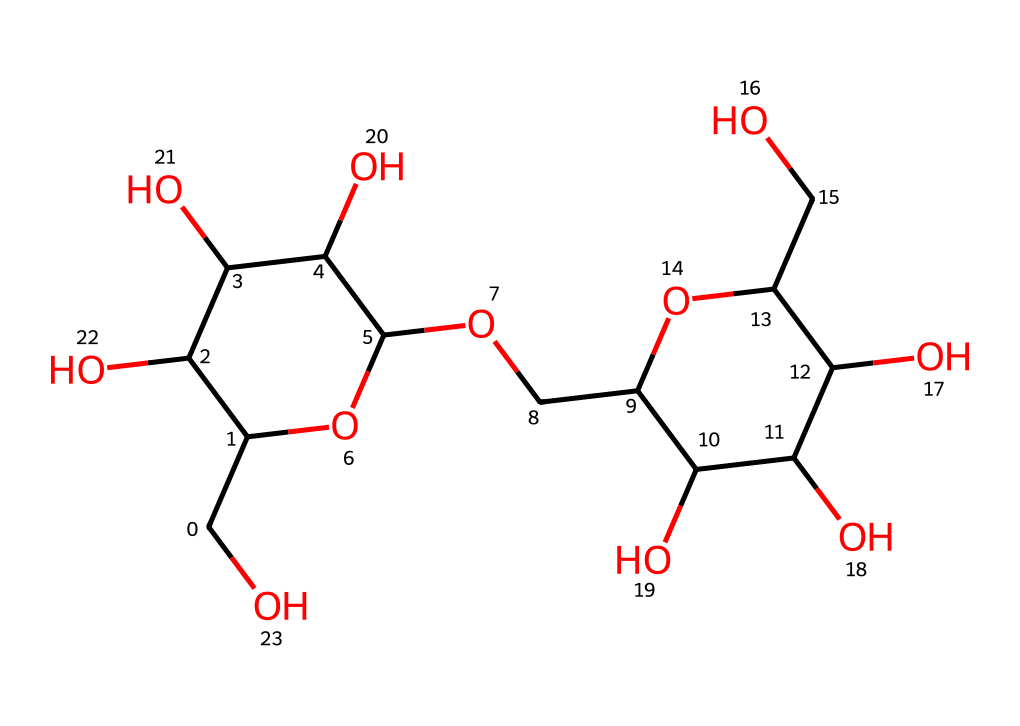What is the primary functional group present in this chemical? The chemical structure includes multiple hydroxyl (-OH) groups, which are characteristic of alcohols and carbohydrates. These hydroxyl groups are responsible for the molecules' polar nature.
Answer: hydroxyl How many carbon atoms are present in the structure? By analyzing the SMILES representation, we can count the number of carbon (C) symbols. In this case, there are 12 carbon atoms in total.
Answer: 12 What type of carbohydrate is represented by this chemical? Given the structure's complexity and branching, along with the presence of multiple sugar units, this chemical is classified as a polysaccharide; specifically, it resembles starch or glycogen.
Answer: polysaccharide What specific role does this carbohydrate play in cognitive performance? Starch is a polysaccharide that serves as an energy source; when broken down, it releases glucose, which is crucial for brain function and cognitive activities.
Answer: energy source How many hydroxyl groups are present in this molecule? By examining the structure, we can identify that there are 6 hydroxyl groups (-OH) incorporated throughout the carbohydrate's structure.
Answer: 6 What type of bonds connect the sugar units in this carbohydrate? The SMILES representation indicates glycosidic linkages between the sugar units, which are specific types of covalent bonds that connect monosaccharides to form disaccharides and polysaccharides.
Answer: glycosidic linkages 